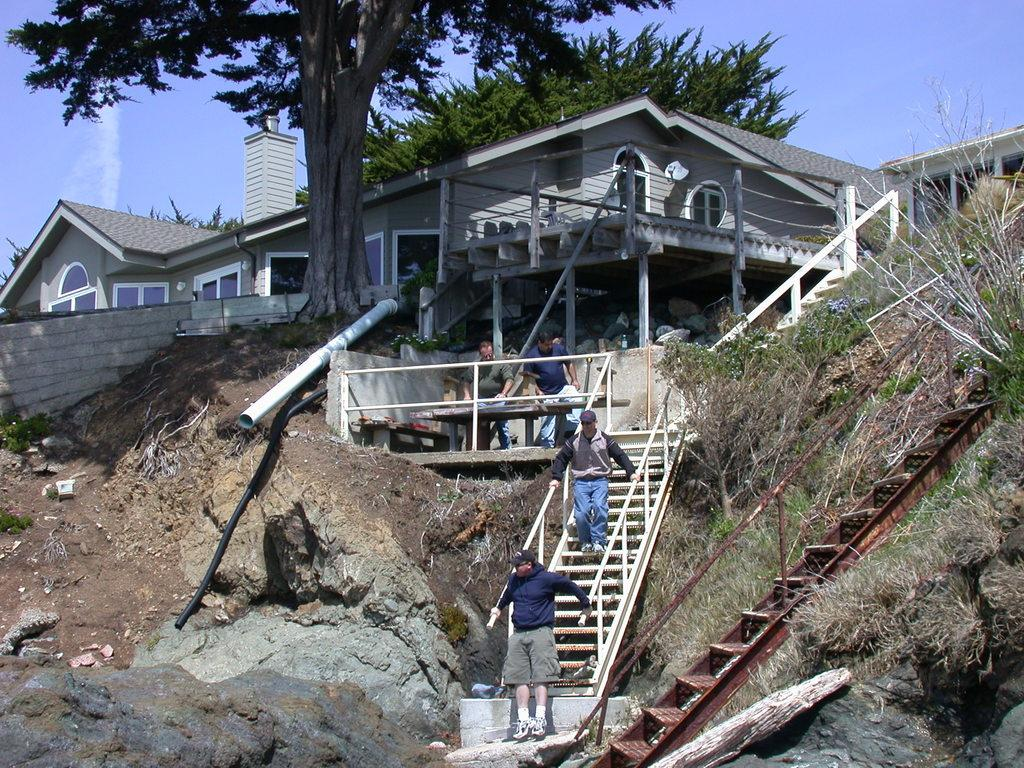What type of house is shown in the image? There is a house with glass windows in the image. What architectural feature can be seen in the image? There are steps in the image. Can you describe the people visible in the image? There are people visible in the image. What type of vegetation is present in the image? Plants and trees are present in the image. What is the color of the sky in the image? The sky is blue in color. Where is the heart-shaped lamp located in the image? There is no heart-shaped lamp present in the image. Can you describe the airplane flying over the house in the image? There is no airplane visible in the image. 